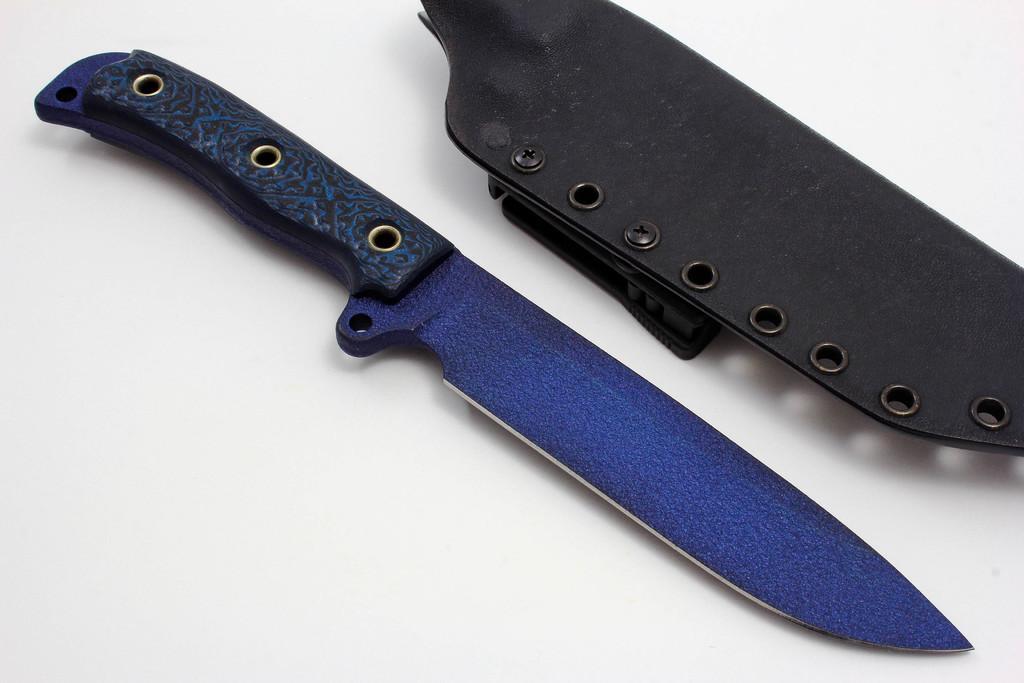Could you give a brief overview of what you see in this image? In this image, we can see a bowie knife which is placed on the surface. 